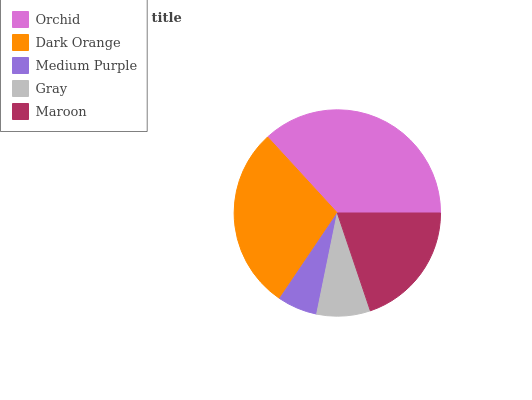Is Medium Purple the minimum?
Answer yes or no. Yes. Is Orchid the maximum?
Answer yes or no. Yes. Is Dark Orange the minimum?
Answer yes or no. No. Is Dark Orange the maximum?
Answer yes or no. No. Is Orchid greater than Dark Orange?
Answer yes or no. Yes. Is Dark Orange less than Orchid?
Answer yes or no. Yes. Is Dark Orange greater than Orchid?
Answer yes or no. No. Is Orchid less than Dark Orange?
Answer yes or no. No. Is Maroon the high median?
Answer yes or no. Yes. Is Maroon the low median?
Answer yes or no. Yes. Is Medium Purple the high median?
Answer yes or no. No. Is Gray the low median?
Answer yes or no. No. 